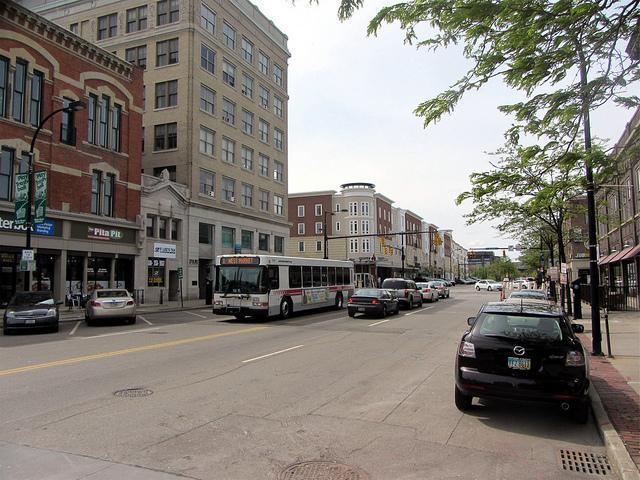How many cars are in this picture?
Give a very brief answer. 10. How many buses do you see?
Give a very brief answer. 1. How many levels is the bus?
Give a very brief answer. 1. How many cars are visible?
Give a very brief answer. 2. 